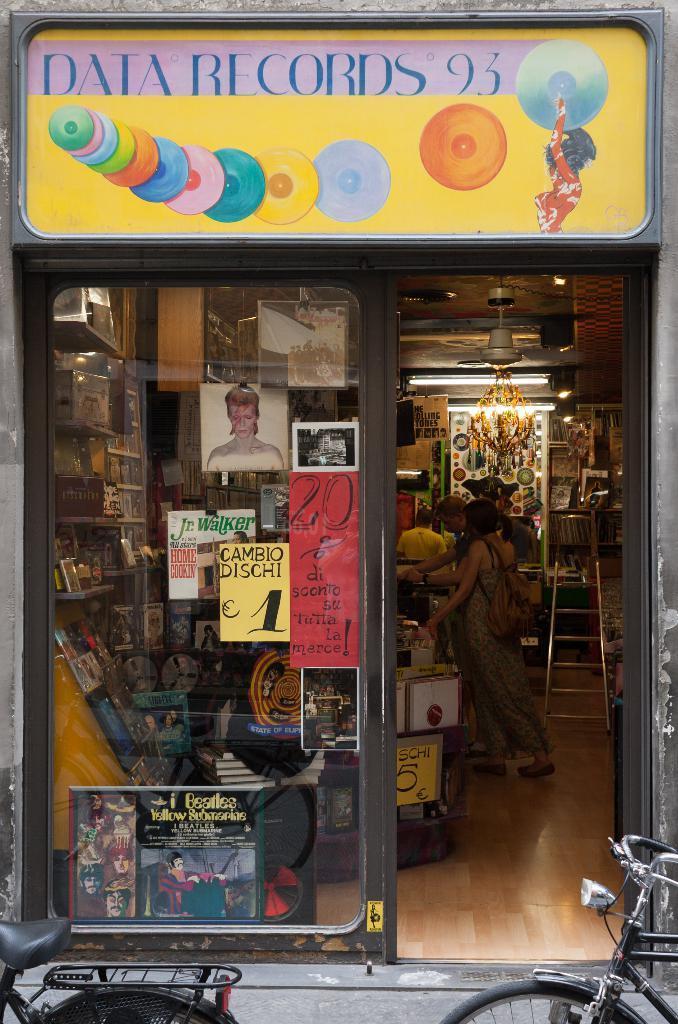Can you describe this image briefly? In this image we can see a store, few people standing inside the store, there is a ladder, a fan to the ceiling and few objects in the store and few posters to the glass and bicycles in front of the store. 